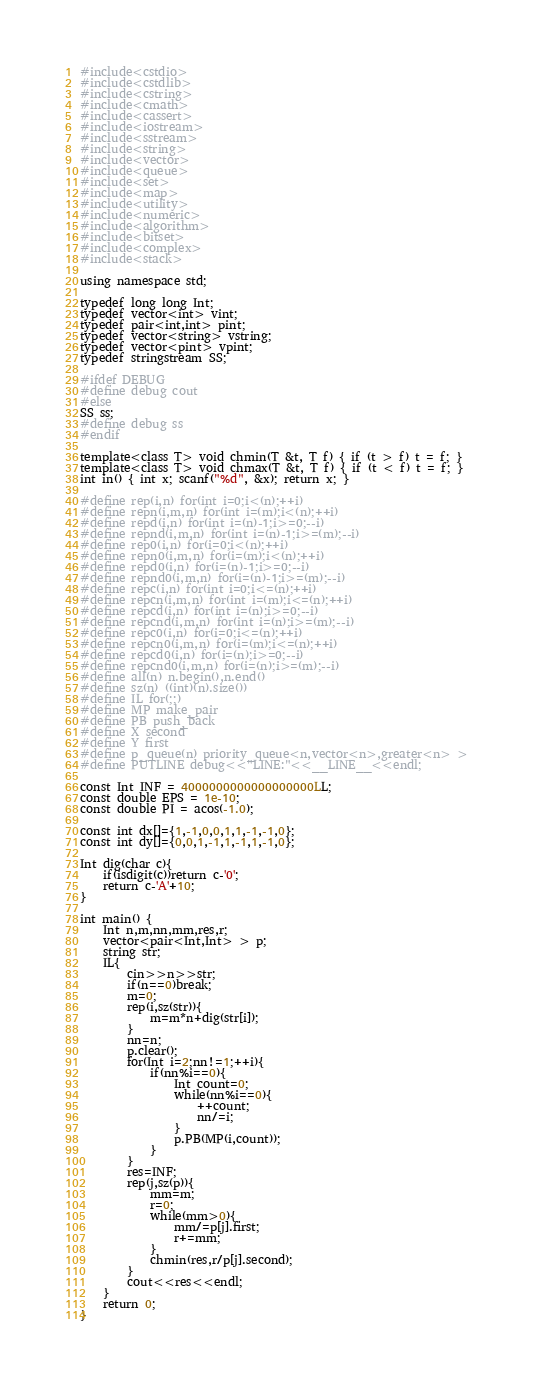<code> <loc_0><loc_0><loc_500><loc_500><_C++_>#include<cstdio>
#include<cstdlib>
#include<cstring>
#include<cmath>
#include<cassert>
#include<iostream>
#include<sstream>
#include<string>
#include<vector>
#include<queue>
#include<set>
#include<map>
#include<utility>
#include<numeric>
#include<algorithm>
#include<bitset>
#include<complex>
#include<stack>

using namespace std;

typedef long long Int;
typedef vector<int> vint;
typedef pair<int,int> pint;
typedef vector<string> vstring;
typedef vector<pint> vpint;
typedef stringstream SS;

#ifdef DEBUG
#define debug cout
#else
SS ss;
#define debug ss
#endif

template<class T> void chmin(T &t, T f) { if (t > f) t = f; }
template<class T> void chmax(T &t, T f) { if (t < f) t = f; }
int in() { int x; scanf("%d", &x); return x; }

#define rep(i,n) for(int i=0;i<(n);++i)
#define repn(i,m,n) for(int i=(m);i<(n);++i)
#define repd(i,n) for(int i=(n)-1;i>=0;--i)
#define repnd(i,m,n) for(int i=(n)-1;i>=(m);--i)
#define rep0(i,n) for(i=0;i<(n);++i)
#define repn0(i,m,n) for(i=(m);i<(n);++i)
#define repd0(i,n) for(i=(n)-1;i>=0;--i)
#define repnd0(i,m,n) for(i=(n)-1;i>=(m);--i)
#define repc(i,n) for(int i=0;i<=(n);++i)
#define repcn(i,m,n) for(int i=(m);i<=(n);++i)
#define repcd(i,n) for(int i=(n);i>=0;--i)
#define repcnd(i,m,n) for(int i=(n);i>=(m);--i)
#define repc0(i,n) for(i=0;i<=(n);++i)
#define repcn0(i,m,n) for(i=(m);i<=(n);++i)
#define repcd0(i,n) for(i=(n);i>=0;--i)
#define repcnd0(i,m,n) for(i=(n);i>=(m);--i)
#define all(n) n.begin(),n.end()
#define sz(n) ((int)(n).size())
#define IL for(;;)
#define MP make_pair
#define PB push_back
#define X second
#define Y first
#define p_queue(n) priority_queue<n,vector<n>,greater<n> >
#define PUTLINE debug<<"LINE:"<<__LINE__<<endl;

const Int INF = 4000000000000000000LL;
const double EPS = 1e-10;
const double PI = acos(-1.0);

const int dx[]={1,-1,0,0,1,1,-1,-1,0};
const int dy[]={0,0,1,-1,1,-1,1,-1,0};

Int dig(char c){
	if(isdigit(c))return c-'0';
	return c-'A'+10;
}

int main() {
	Int n,m,nn,mm,res,r;
	vector<pair<Int,Int> > p;
	string str;
	IL{
		cin>>n>>str;
		if(n==0)break;
		m=0;
		rep(i,sz(str)){
			m=m*n+dig(str[i]);
		}
		nn=n;
		p.clear();
		for(Int i=2;nn!=1;++i){
			if(nn%i==0){
				Int count=0;
				while(nn%i==0){
					++count;
					nn/=i;
				}
				p.PB(MP(i,count));
			}
		}
		res=INF;
		rep(j,sz(p)){
			mm=m;
			r=0;
			while(mm>0){
				mm/=p[j].first;
				r+=mm;
			}
			chmin(res,r/p[j].second);
		}
		cout<<res<<endl;
	}
	return 0;
}</code> 